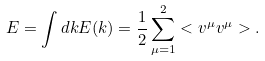Convert formula to latex. <formula><loc_0><loc_0><loc_500><loc_500>E = \int d k E ( k ) = \frac { 1 } { 2 } \sum _ { \mu = 1 } ^ { 2 } < v ^ { \mu } v ^ { \mu } > .</formula> 